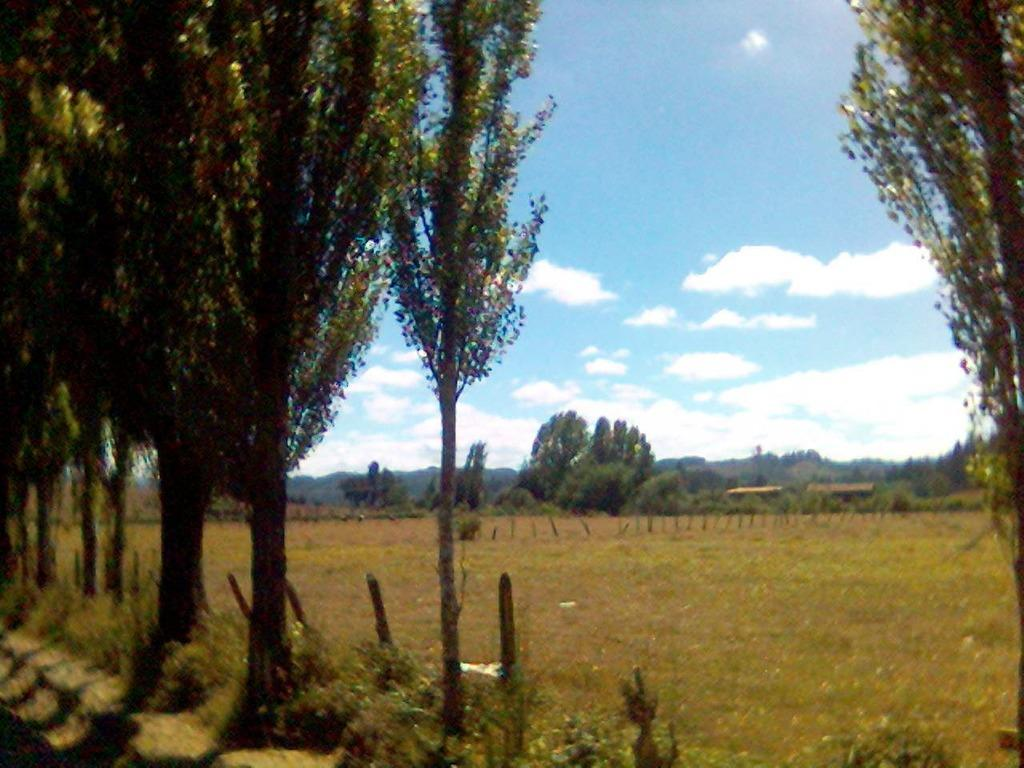What type of vegetation can be seen in the image? There are trees and plants in the image. What is visible at the top of the image? The sky is visible at the top of the image. Can you tell me how many women are depicted in the image? There are no women present in the image; it features trees, plants, and the sky. What type of lock is visible in the image? There is no lock present in the image. 